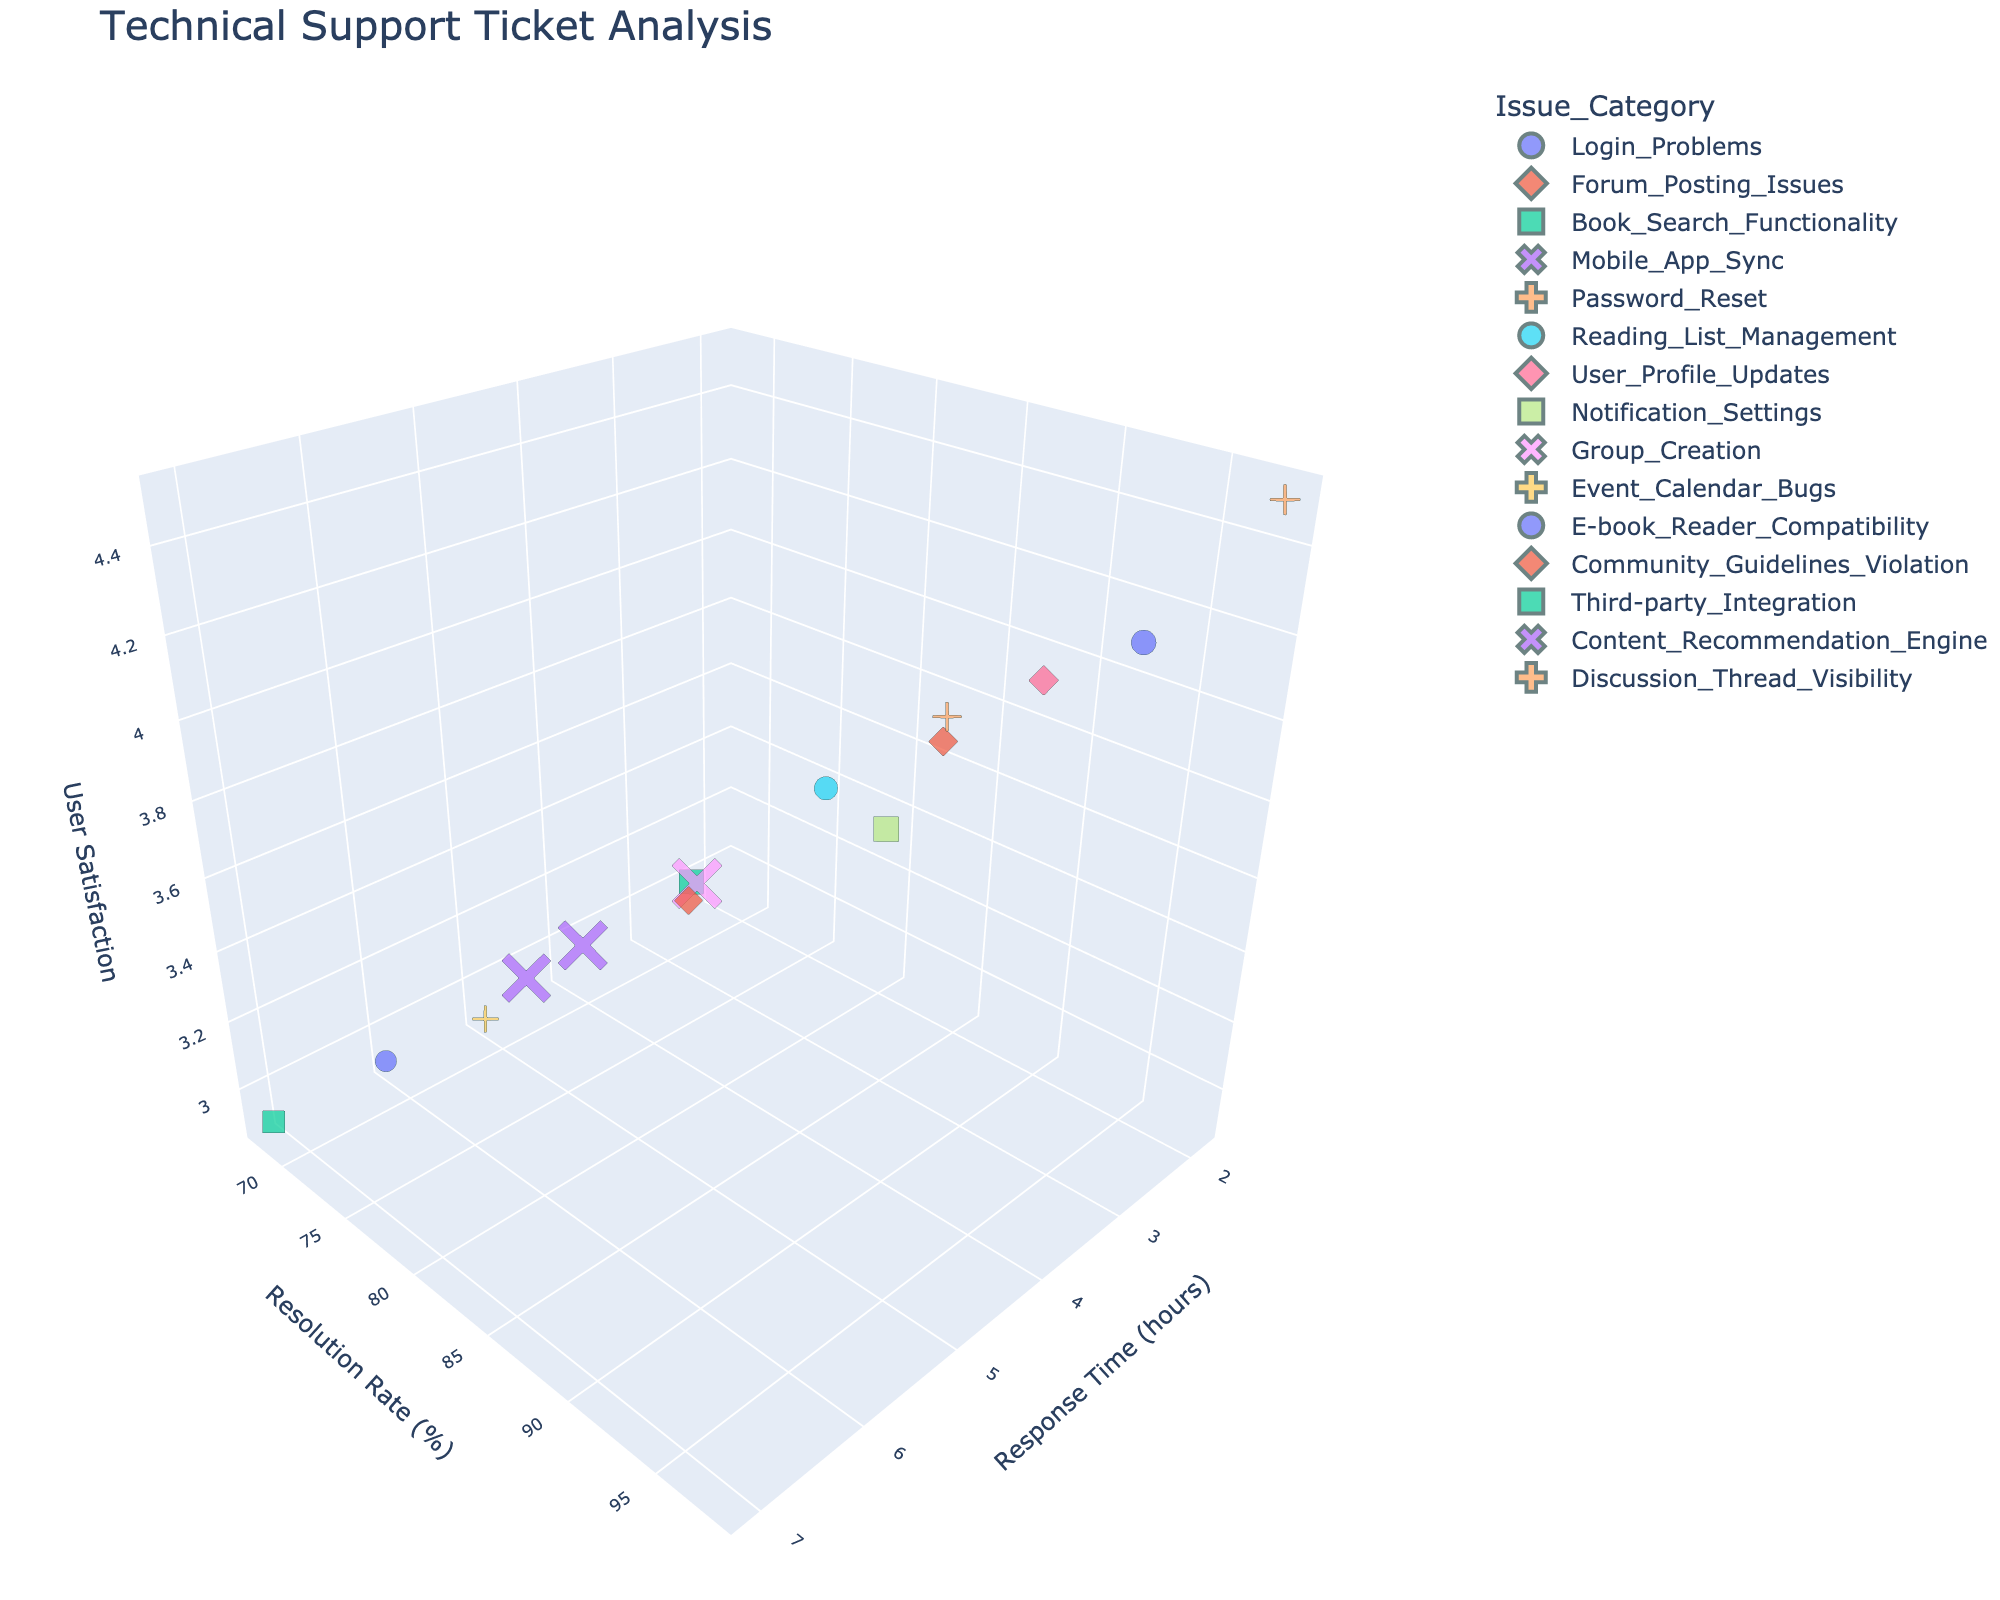What does the title of the plot say? The title of the plot is displayed at the top of the figure. From the context, it can be inferred that the title indicates the analysis being conducted.
Answer: "Technical Support Ticket Analysis" What are the units for 'Response Time'? The 'Response Time' axis label will indicate its units. The context specifies 'Response Time (hours)'.
Answer: Hours Which issue category has the highest user satisfaction score? To find this, look at the 'User Satisfaction Score' axis (Z-axis) and identify the category corresponding to the highest point.
Answer: Password_Reset Is there a relationship between 'Response Time' and 'User Satisfaction Score'? Generally, observe whether higher or lower 'Response Time' corresponds to higher or lower 'User Satisfaction Score'. If there is a downward trend in satisfaction with increasing response time, there is a negative relationship.
Answer: Generally, a negative relationship Which issue category took the longest response time? Identify the highest point on the 'Response Time (hours)' axis (X-axis).
Answer: Third-party_Integration What's the average resolution rate across all issue categories? Sum all resolution rates and divide by the number of issue categories: (95 + 88 + 82 + 78 + 98 + 85 + 92 + 87 + 80 + 75 + 70 + 83 + 68 + 76 + 89) / 15 = 82.0667
Answer: 82.067% Compare the user satisfaction scores of 'Login_Problems' and 'Content_Recommendation_Engine'. Which one is higher? Observe the user satisfaction scores for both categories on the Z-axis.
Answer: Login_Problems Which category has the highest resolution rate for issues related to book reading features? Focus on book reading-related categories such as 'Book_Search_Functionality' and 'E-book_Reader_Compatibility' and identify the category with the higher resolution rate.
Answer: Book_Search_Functionality 